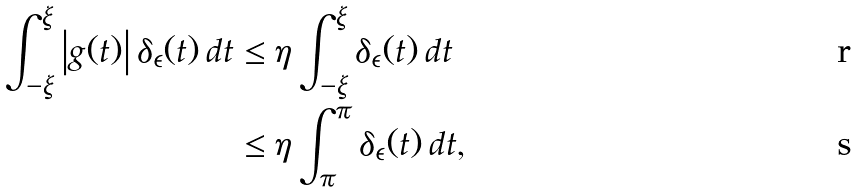<formula> <loc_0><loc_0><loc_500><loc_500>\int _ { - \xi } ^ { \xi } \left | g ( t ) \right | \delta _ { \epsilon } ( t ) \, d t & \leq \eta \int _ { - \xi } ^ { \xi } \delta _ { \epsilon } ( t ) \, d t \\ & \leq \eta \int _ { \pi } ^ { \pi } \delta _ { \epsilon } ( t ) \, d t \text {,}</formula> 